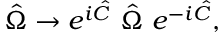<formula> <loc_0><loc_0><loc_500><loc_500>\hat { \Omega } \rightarrow e ^ { i \hat { C } } \hat { \Omega } e ^ { - i \hat { C } } ,</formula> 